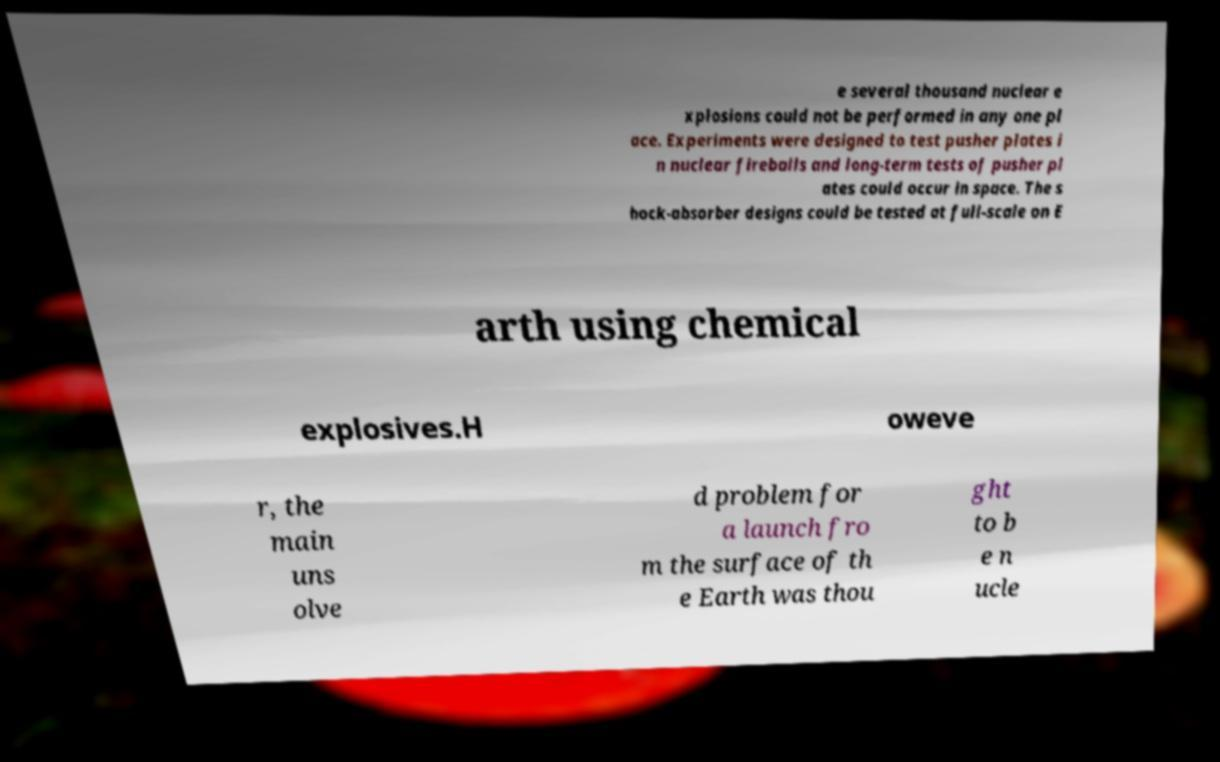Please identify and transcribe the text found in this image. e several thousand nuclear e xplosions could not be performed in any one pl ace. Experiments were designed to test pusher plates i n nuclear fireballs and long-term tests of pusher pl ates could occur in space. The s hock-absorber designs could be tested at full-scale on E arth using chemical explosives.H oweve r, the main uns olve d problem for a launch fro m the surface of th e Earth was thou ght to b e n ucle 